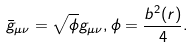Convert formula to latex. <formula><loc_0><loc_0><loc_500><loc_500>\bar { g } _ { \mu \nu } = \sqrt { \phi } g _ { \mu \nu } , \phi = \frac { b ^ { 2 } ( r ) } { 4 } .</formula> 